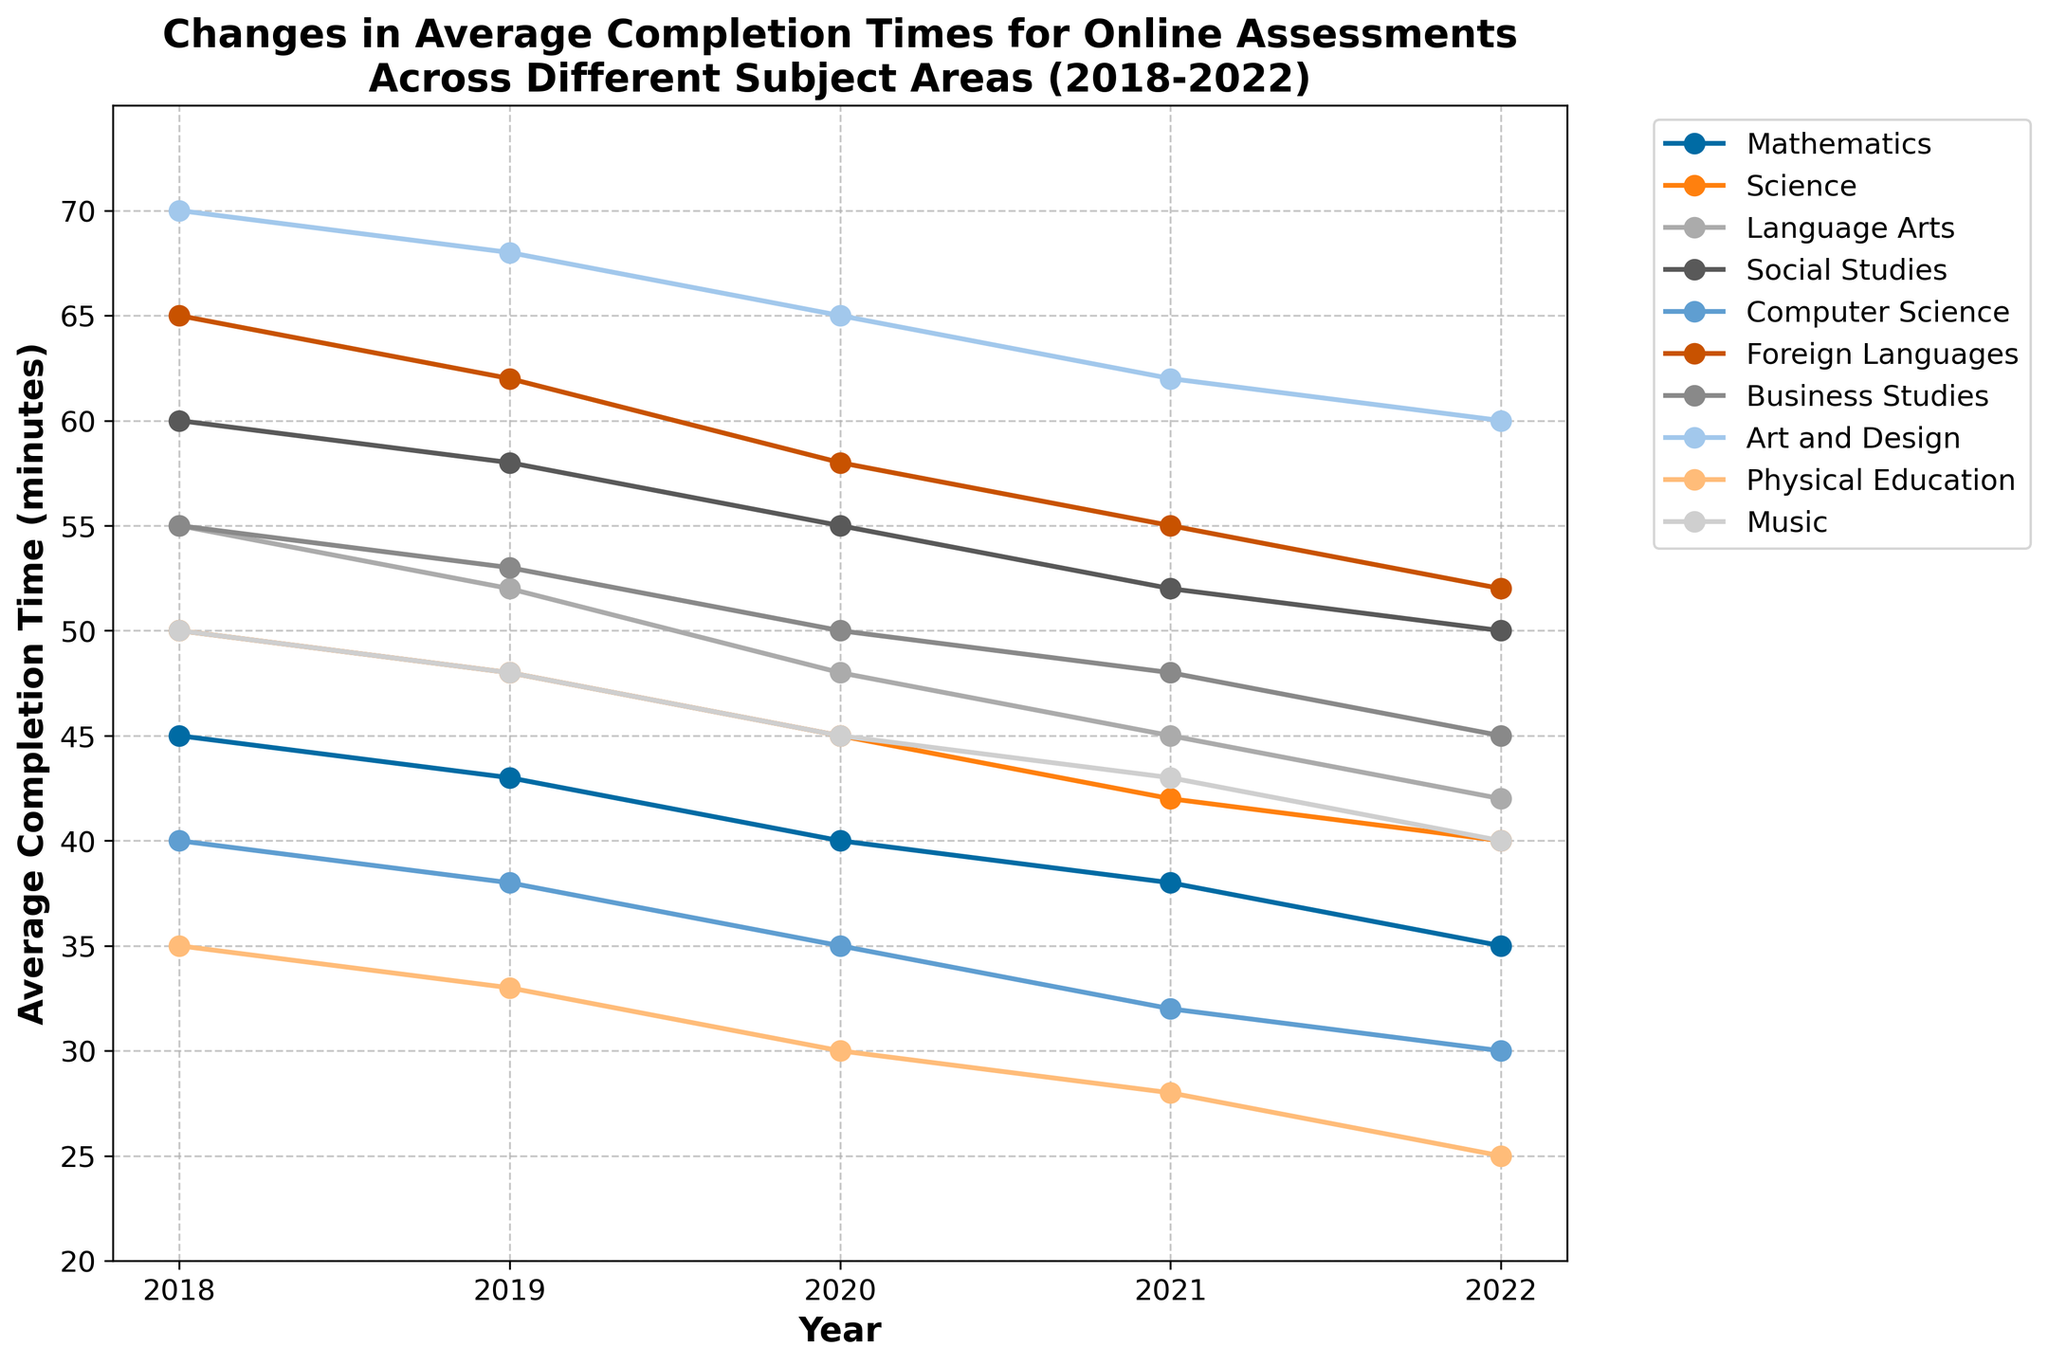What is the trend in average completion times for online assessments in Mathematics from 2018 to 2022? The line for Mathematics moves downward from 45 minutes in 2018 to 35 minutes in 2022, indicating a decreasing trend in completion times.
Answer: Decreasing Which subject had the highest average completion time in 2022? In 2022, the highest point on the y-axis corresponds to Art and Design with approximately 60 minutes.
Answer: Art and Design How does the average completion time for Science in 2022 compare to that in 2018? The average completion time for Science in 2022 is 40 minutes, while in 2018 it was 50 minutes. The difference is 50 - 40 = 10 minutes.
Answer: 10 minutes less What is the average completion time for Business Studies and Social Studies in 2020? For Business Studies in 2020, the value is 50 minutes, and for Social Studies in 2020, it is 55 minutes. The average of these two values is (50 + 55) / 2 = 52.5 minutes.
Answer: 52.5 minutes Which subject area showed the most significant decrease in average completion time over the five years? Comparing the differences from 2018 to 2022, we see Foreign Languages decreased from 65 to 52, a difference of 13 minutes; Art and Design decreased from 70 to 60, a difference of 10 minutes; etc. The largest decrease is for Foreign Languages at 13 minutes.
Answer: Foreign Languages Do any subjects maintain the same ranking in terms of completion time from the start year (2018) to the end year (2022)? By comparing the rankings for each year in 2018 and 2022, we see that Foreign Languages remains the highest in both years.
Answer: Yes, Foreign Languages What is the relative change in completion times for Physical Education from 2018 to 2022? The completion time for Physical Education in 2018 was 35 minutes, and in 2022 it was 25 minutes. The relative change is (35 - 25) / 35 = 10 / 35 ≈ 0.286 or 28.6%.
Answer: 28.6% Which subject showed the least change in average completion time over the observed period? By calculating the absolute differences for each subject over the years, Music shows the least change, going from 50 to 40 minutes, a difference of 10 minutes, which is equally the smallest decrease observed along with Art and Design. However, Music reaches this minimum difference first in the list.
Answer: Music Is the change in average completion times for Language Arts and Social Studies from 2018 to 2022 similar or different? Language Arts decreases from 55 to 42 minutes (a change of 13 minutes), Social Studies decreases from 60 to 50 minutes (a change of 10 minutes). The changes are different; Language Arts has a larger decrease.
Answer: Different 